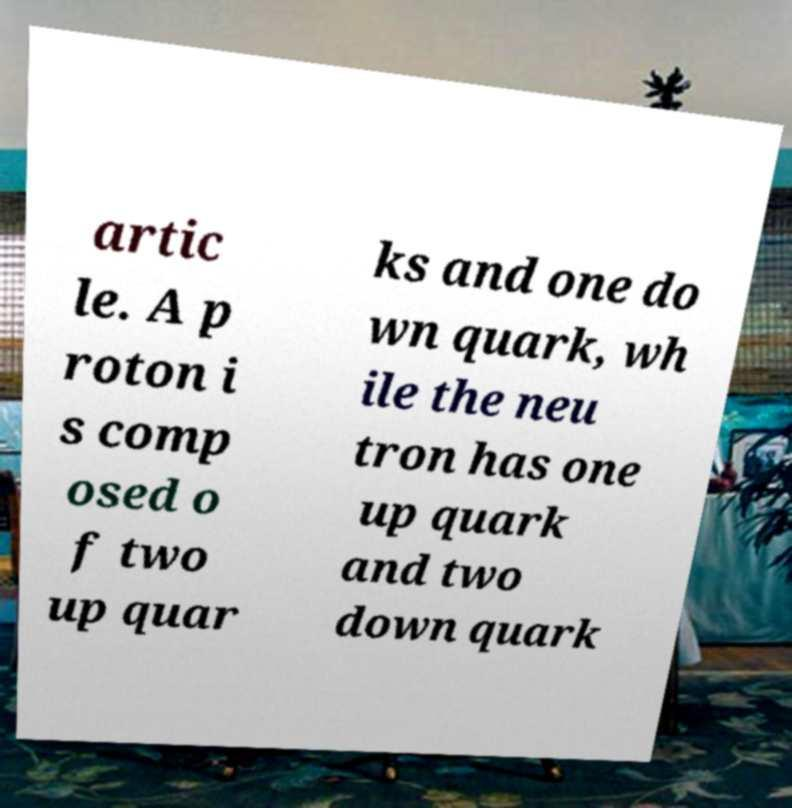Can you accurately transcribe the text from the provided image for me? artic le. A p roton i s comp osed o f two up quar ks and one do wn quark, wh ile the neu tron has one up quark and two down quark 